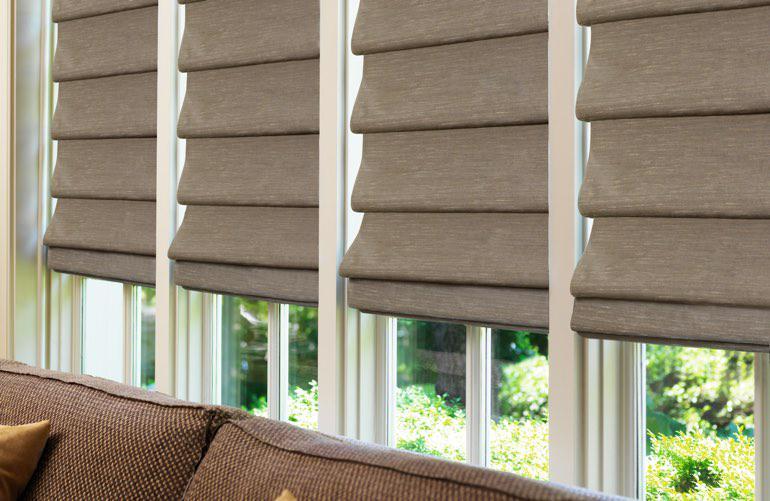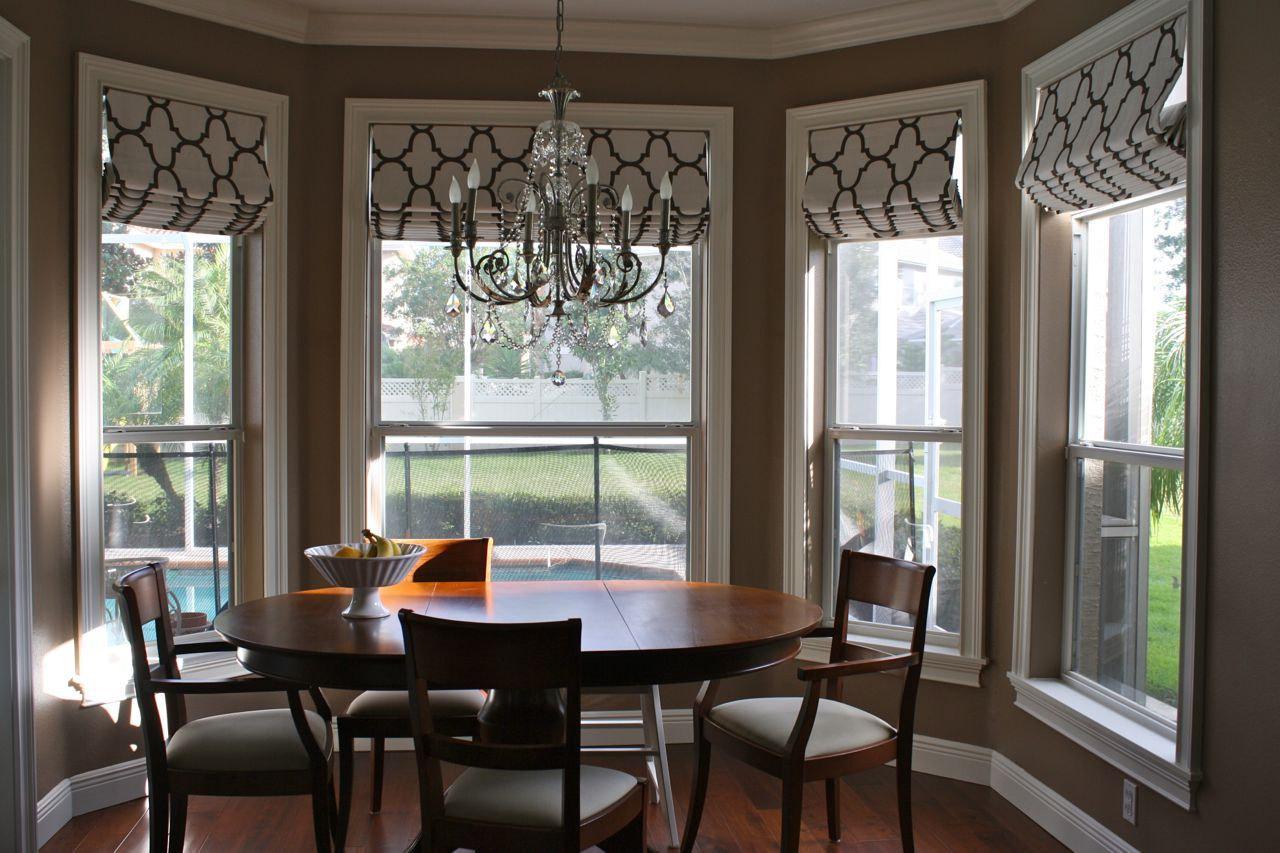The first image is the image on the left, the second image is the image on the right. Analyze the images presented: Is the assertion "The right image features a room with at least three windows with rolled up shades printed with bold geometric patterns." valid? Answer yes or no. Yes. The first image is the image on the left, the second image is the image on the right. For the images displayed, is the sentence "In at least one image there is a total of four beige blinds behind a sofa." factually correct? Answer yes or no. Yes. 